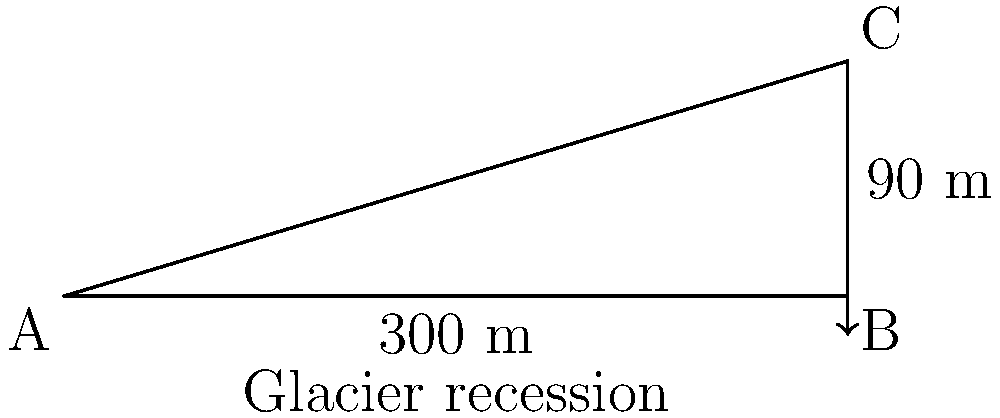As a freelance photographer documenting geological changes, you're capturing the recession of a glacier. The glacier's edge has retreated 300 meters horizontally and decreased in height by 90 meters. What is the angle of inclination (in degrees) of the glacier's surface relative to the horizontal plane? To find the angle of inclination, we can use trigonometry. Let's approach this step-by-step:

1) The glacier forms a right-angled triangle with:
   - Base (horizontal distance) = 300 meters
   - Height (vertical distance) = 90 meters
   - Hypotenuse (glacier surface)

2) We need to find the angle between the base and the hypotenuse. This is the angle of inclination.

3) In a right-angled triangle, tangent of an angle is the ratio of the opposite side to the adjacent side.

4) In this case:
   $\tan(\theta) = \frac{\text{opposite}}{\text{adjacent}} = \frac{90}{300} = \frac{3}{10} = 0.3$

5) To find the angle, we need to use the inverse tangent (arctan or $\tan^{-1}$):
   $\theta = \tan^{-1}(0.3)$

6) Using a calculator or trigonometric tables:
   $\theta \approx 16.70^\circ$

7) Rounding to the nearest degree:
   $\theta \approx 17^\circ$

Therefore, the angle of inclination of the glacier's surface is approximately 17 degrees.
Answer: $17^\circ$ 